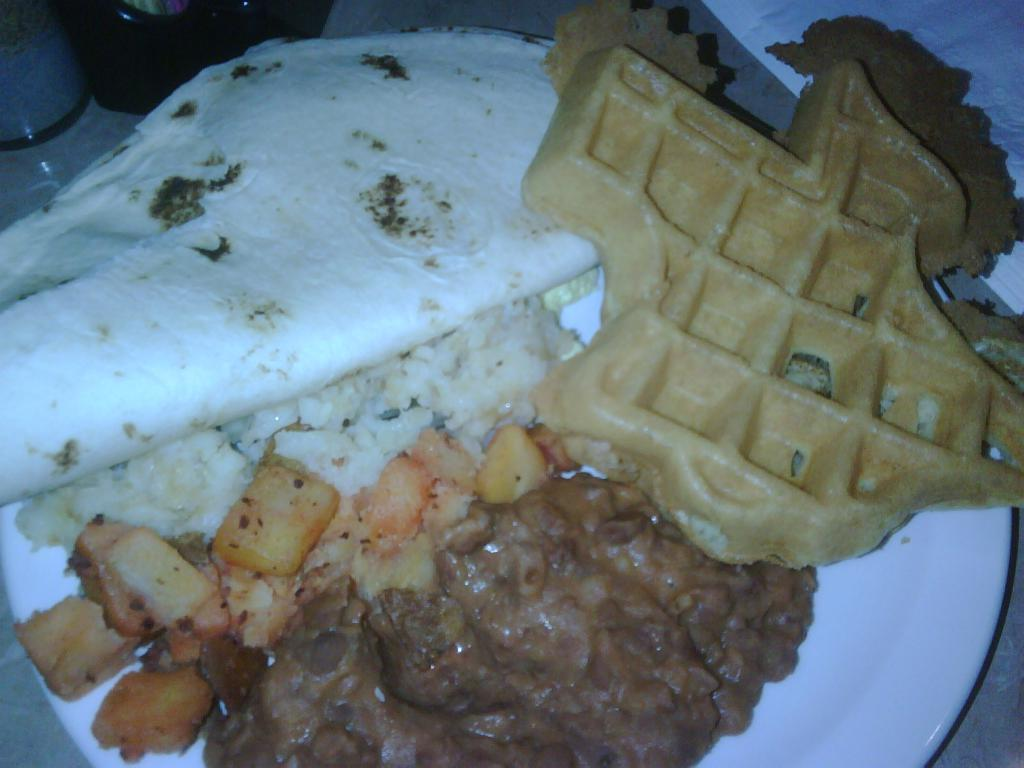What is on the plate in the image? There is a food item on the plate in the image. Are there any other items near the plate in the image? There may be containers beside the plate in the image. What type of operation is being performed on the cattle in the image? There is no cattle or operation present in the image; it only features a plate with a food item and possibly containers. What type of substance is being used to enhance the food item in the image? There is no information about any substance being used to enhance the food item in the image. 